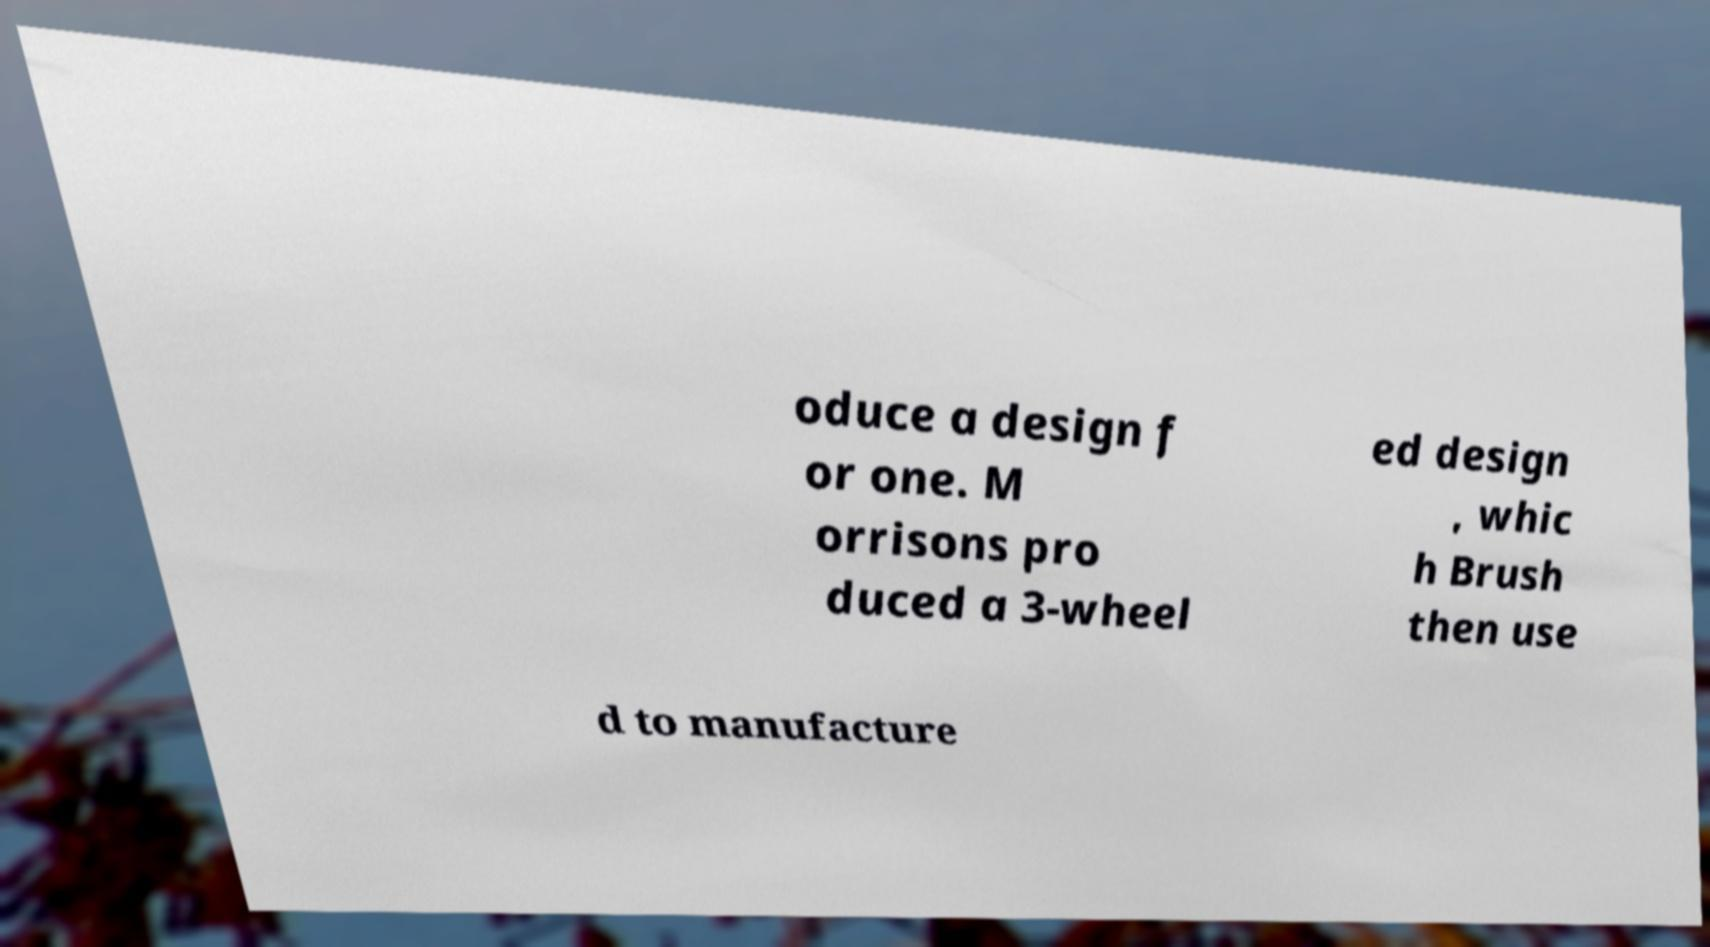Can you read and provide the text displayed in the image?This photo seems to have some interesting text. Can you extract and type it out for me? oduce a design f or one. M orrisons pro duced a 3-wheel ed design , whic h Brush then use d to manufacture 